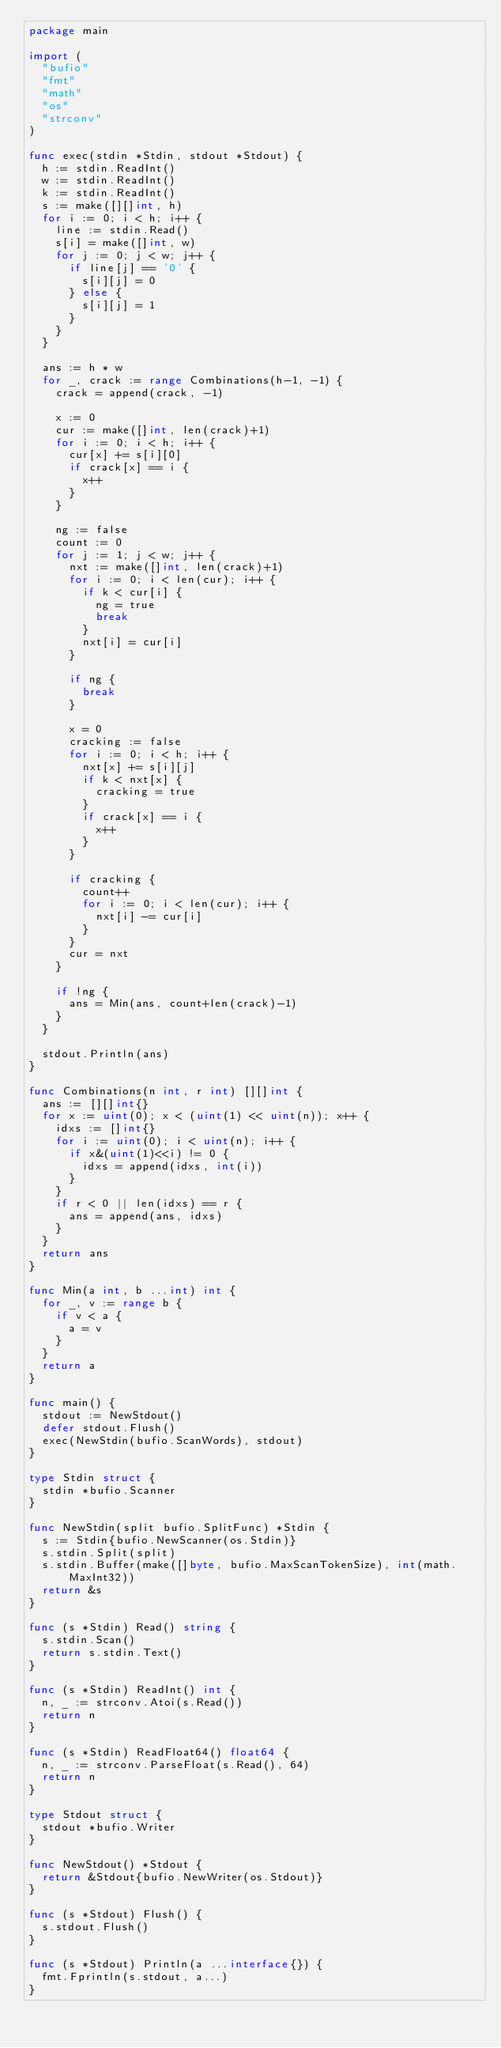<code> <loc_0><loc_0><loc_500><loc_500><_Go_>package main

import (
	"bufio"
	"fmt"
	"math"
	"os"
	"strconv"
)

func exec(stdin *Stdin, stdout *Stdout) {
	h := stdin.ReadInt()
	w := stdin.ReadInt()
	k := stdin.ReadInt()
	s := make([][]int, h)
	for i := 0; i < h; i++ {
		line := stdin.Read()
		s[i] = make([]int, w)
		for j := 0; j < w; j++ {
			if line[j] == '0' {
				s[i][j] = 0
			} else {
				s[i][j] = 1
			}
		}
	}

	ans := h * w
	for _, crack := range Combinations(h-1, -1) {
		crack = append(crack, -1)

		x := 0
		cur := make([]int, len(crack)+1)
		for i := 0; i < h; i++ {
			cur[x] += s[i][0]
			if crack[x] == i {
				x++
			}
		}

		ng := false
		count := 0
		for j := 1; j < w; j++ {
			nxt := make([]int, len(crack)+1)
			for i := 0; i < len(cur); i++ {
				if k < cur[i] {
					ng = true
					break
				}
				nxt[i] = cur[i]
			}

			if ng {
				break
			}

			x = 0
			cracking := false
			for i := 0; i < h; i++ {
				nxt[x] += s[i][j]
				if k < nxt[x] {
					cracking = true
				}
				if crack[x] == i {
					x++
				}
			}

			if cracking {
				count++
				for i := 0; i < len(cur); i++ {
					nxt[i] -= cur[i]
				}
			}
			cur = nxt
		}

		if !ng {
			ans = Min(ans, count+len(crack)-1)
		}
	}

	stdout.Println(ans)
}

func Combinations(n int, r int) [][]int {
	ans := [][]int{}
	for x := uint(0); x < (uint(1) << uint(n)); x++ {
		idxs := []int{}
		for i := uint(0); i < uint(n); i++ {
			if x&(uint(1)<<i) != 0 {
				idxs = append(idxs, int(i))
			}
		}
		if r < 0 || len(idxs) == r {
			ans = append(ans, idxs)
		}
	}
	return ans
}

func Min(a int, b ...int) int {
	for _, v := range b {
		if v < a {
			a = v
		}
	}
	return a
}

func main() {
	stdout := NewStdout()
	defer stdout.Flush()
	exec(NewStdin(bufio.ScanWords), stdout)
}

type Stdin struct {
	stdin *bufio.Scanner
}

func NewStdin(split bufio.SplitFunc) *Stdin {
	s := Stdin{bufio.NewScanner(os.Stdin)}
	s.stdin.Split(split)
	s.stdin.Buffer(make([]byte, bufio.MaxScanTokenSize), int(math.MaxInt32))
	return &s
}

func (s *Stdin) Read() string {
	s.stdin.Scan()
	return s.stdin.Text()
}

func (s *Stdin) ReadInt() int {
	n, _ := strconv.Atoi(s.Read())
	return n
}

func (s *Stdin) ReadFloat64() float64 {
	n, _ := strconv.ParseFloat(s.Read(), 64)
	return n
}

type Stdout struct {
	stdout *bufio.Writer
}

func NewStdout() *Stdout {
	return &Stdout{bufio.NewWriter(os.Stdout)}
}

func (s *Stdout) Flush() {
	s.stdout.Flush()
}

func (s *Stdout) Println(a ...interface{}) {
	fmt.Fprintln(s.stdout, a...)
}
</code> 